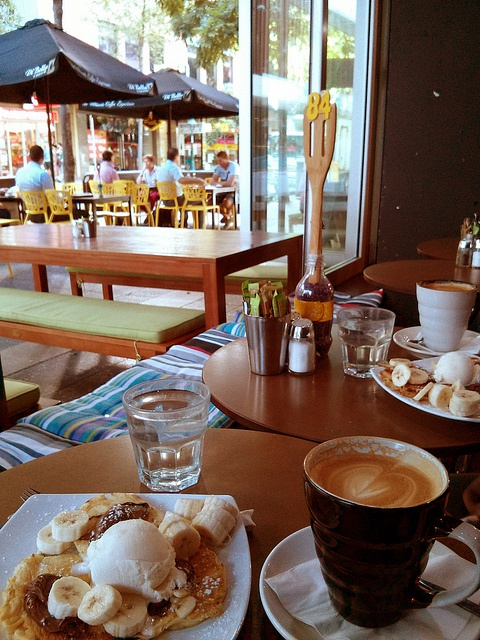Describe the objects in this image and their specific colors. I can see dining table in darkgray, black, maroon, and gray tones, cup in darkgray, black, brown, gray, and maroon tones, dining table in darkgray, lightgray, brown, and maroon tones, dining table in darkgray, maroon, gray, and black tones, and bench in darkgray, brown, tan, and beige tones in this image. 